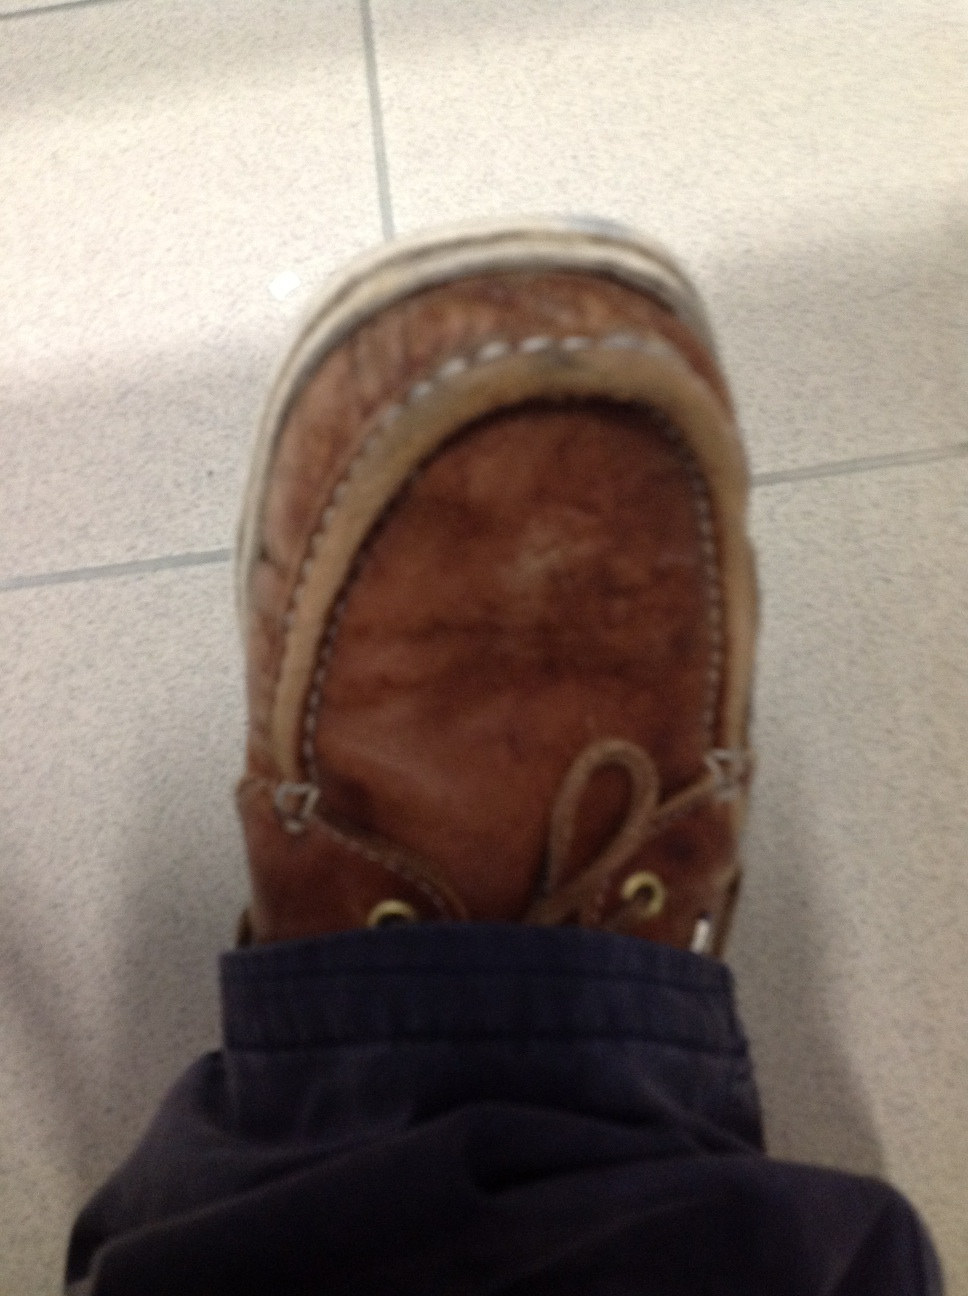What is this? This is a brown leather loafer. Loafers are a type of slip-on shoe that are typically low and lace-less, designed for casual wear. The one in the image appears to have a worn, vintage look with distinct stitching details. 